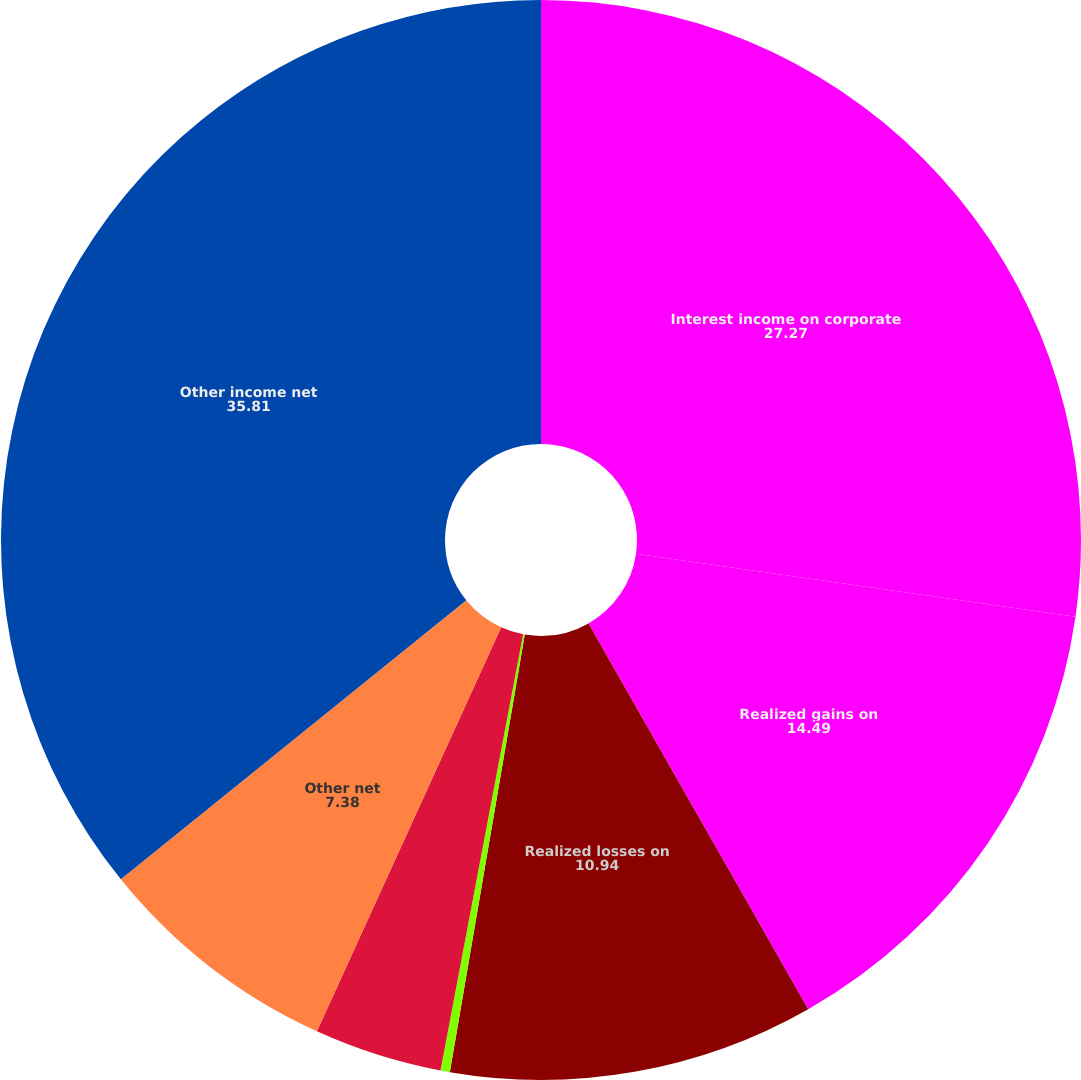Convert chart to OTSL. <chart><loc_0><loc_0><loc_500><loc_500><pie_chart><fcel>Interest income on corporate<fcel>Realized gains on<fcel>Realized losses on<fcel>Realized gains on investment<fcel>Net loss (gain) on sales of<fcel>Other net<fcel>Other income net<nl><fcel>27.27%<fcel>14.49%<fcel>10.94%<fcel>0.28%<fcel>3.83%<fcel>7.38%<fcel>35.81%<nl></chart> 